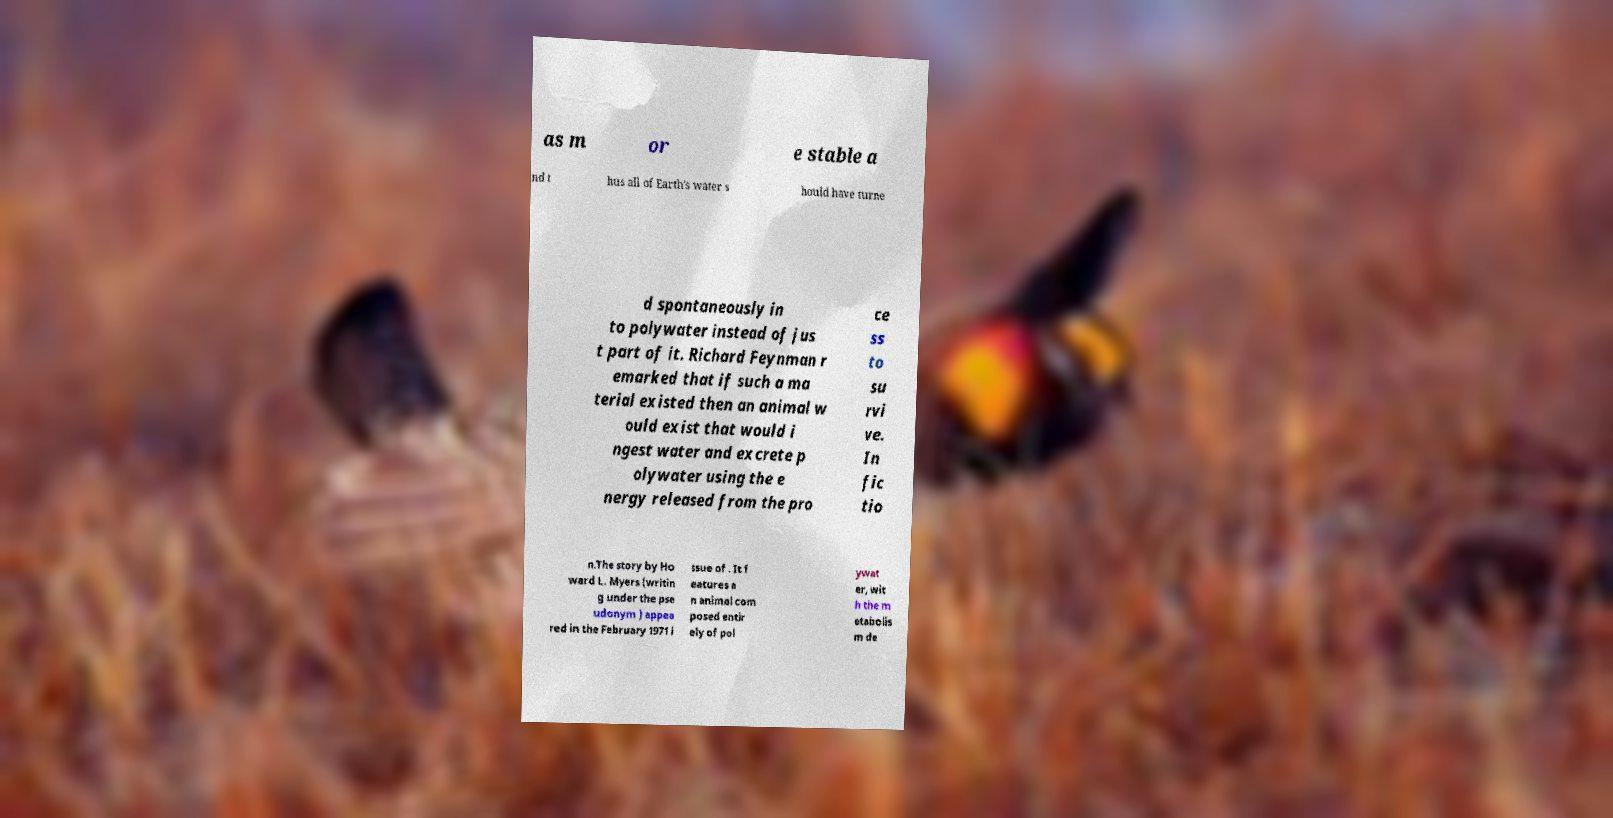For documentation purposes, I need the text within this image transcribed. Could you provide that? as m or e stable a nd t hus all of Earth's water s hould have turne d spontaneously in to polywater instead of jus t part of it. Richard Feynman r emarked that if such a ma terial existed then an animal w ould exist that would i ngest water and excrete p olywater using the e nergy released from the pro ce ss to su rvi ve. In fic tio n.The story by Ho ward L. Myers (writin g under the pse udonym ) appea red in the February 1971 i ssue of . It f eatures a n animal com posed entir ely of pol ywat er, wit h the m etabolis m de 